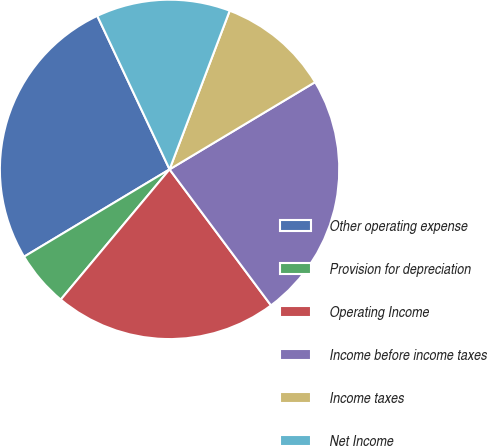Convert chart. <chart><loc_0><loc_0><loc_500><loc_500><pie_chart><fcel>Other operating expense<fcel>Provision for depreciation<fcel>Operating Income<fcel>Income before income taxes<fcel>Income taxes<fcel>Net Income<nl><fcel>26.6%<fcel>5.32%<fcel>21.28%<fcel>23.4%<fcel>10.64%<fcel>12.77%<nl></chart> 